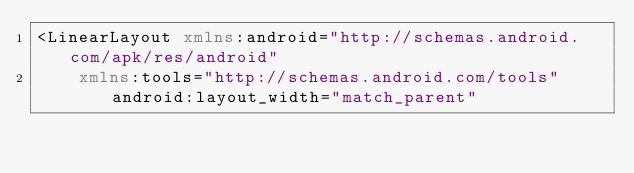Convert code to text. <code><loc_0><loc_0><loc_500><loc_500><_XML_><LinearLayout xmlns:android="http://schemas.android.com/apk/res/android"
    xmlns:tools="http://schemas.android.com/tools" android:layout_width="match_parent"</code> 